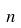Convert formula to latex. <formula><loc_0><loc_0><loc_500><loc_500>n</formula> 